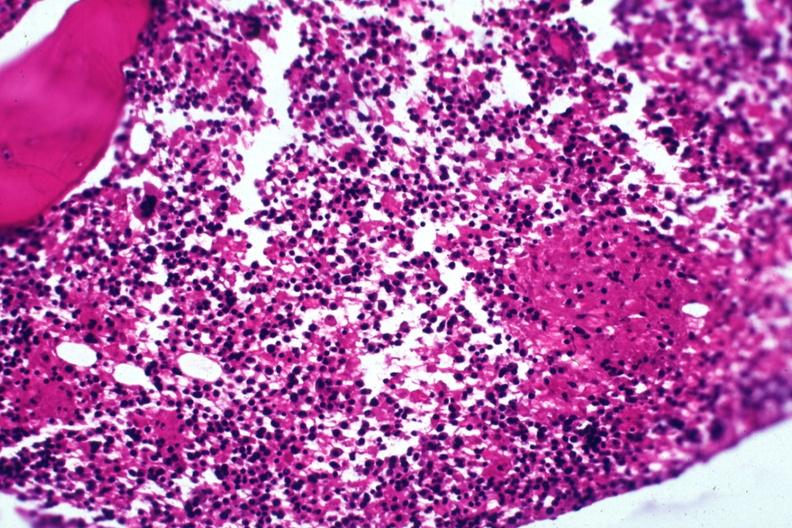what does this image show?
Answer the question using a single word or phrase. Section granuloma shown but not too typical 